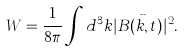<formula> <loc_0><loc_0><loc_500><loc_500>W = \frac { 1 } { 8 \pi } \int d ^ { 3 } k | B ( \vec { k } , t ) | ^ { 2 } .</formula> 